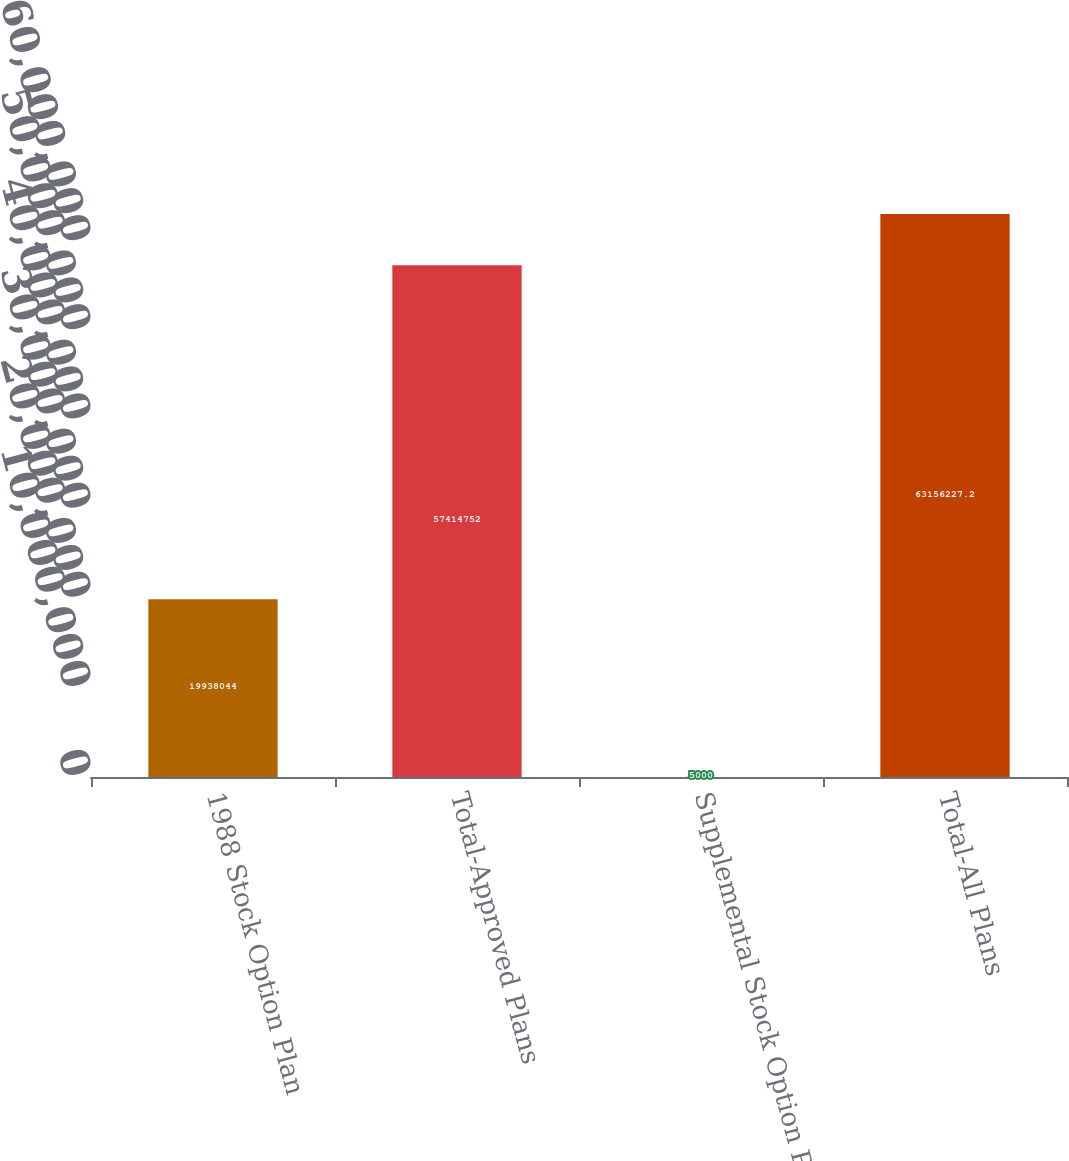Convert chart to OTSL. <chart><loc_0><loc_0><loc_500><loc_500><bar_chart><fcel>1988 Stock Option Plan<fcel>Total-Approved Plans<fcel>Supplemental Stock Option Plan<fcel>Total-All Plans<nl><fcel>1.9938e+07<fcel>5.74148e+07<fcel>5000<fcel>6.31562e+07<nl></chart> 